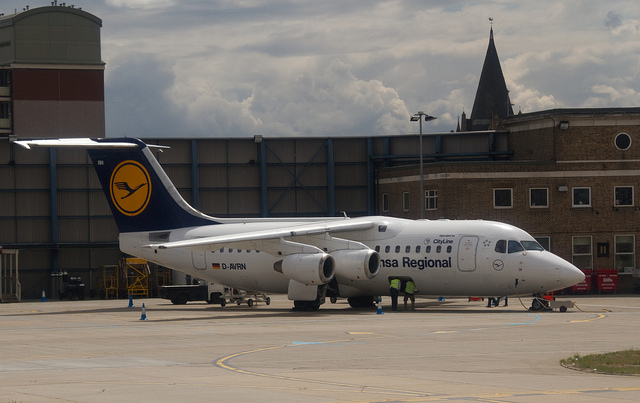Identify and read out the text in this image. lsa Regional 